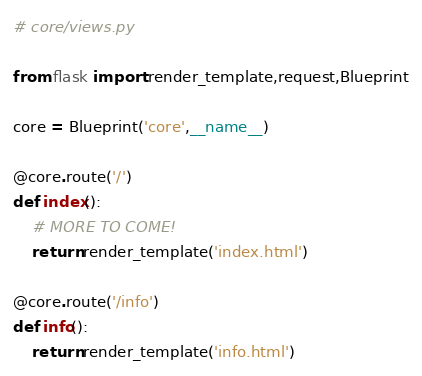<code> <loc_0><loc_0><loc_500><loc_500><_Python_># core/views.py

from flask import render_template,request,Blueprint

core = Blueprint('core',__name__)

@core.route('/')
def index():
    # MORE TO COME!
    return render_template('index.html')

@core.route('/info')
def info():
    return render_template('info.html')
</code> 